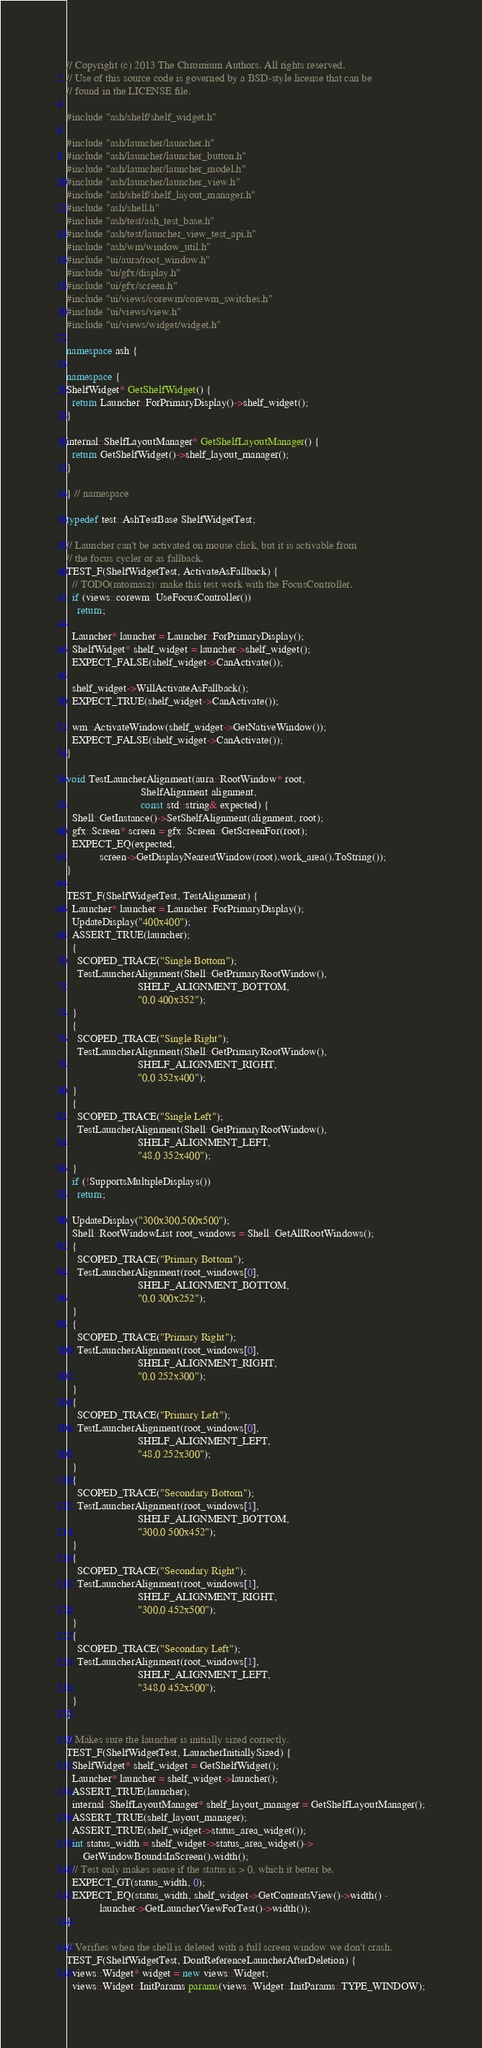Convert code to text. <code><loc_0><loc_0><loc_500><loc_500><_C++_>// Copyright (c) 2013 The Chromium Authors. All rights reserved.
// Use of this source code is governed by a BSD-style license that can be
// found in the LICENSE file.

#include "ash/shelf/shelf_widget.h"

#include "ash/launcher/launcher.h"
#include "ash/launcher/launcher_button.h"
#include "ash/launcher/launcher_model.h"
#include "ash/launcher/launcher_view.h"
#include "ash/shelf/shelf_layout_manager.h"
#include "ash/shell.h"
#include "ash/test/ash_test_base.h"
#include "ash/test/launcher_view_test_api.h"
#include "ash/wm/window_util.h"
#include "ui/aura/root_window.h"
#include "ui/gfx/display.h"
#include "ui/gfx/screen.h"
#include "ui/views/corewm/corewm_switches.h"
#include "ui/views/view.h"
#include "ui/views/widget/widget.h"

namespace ash {

namespace {
ShelfWidget* GetShelfWidget() {
  return Launcher::ForPrimaryDisplay()->shelf_widget();
}

internal::ShelfLayoutManager* GetShelfLayoutManager() {
  return GetShelfWidget()->shelf_layout_manager();
}

} // namespace

typedef test::AshTestBase ShelfWidgetTest;

// Launcher can't be activated on mouse click, but it is activable from
// the focus cycler or as fallback.
TEST_F(ShelfWidgetTest, ActivateAsFallback) {
  // TODO(mtomasz): make this test work with the FocusController.
  if (views::corewm::UseFocusController())
    return;

  Launcher* launcher = Launcher::ForPrimaryDisplay();
  ShelfWidget* shelf_widget = launcher->shelf_widget();
  EXPECT_FALSE(shelf_widget->CanActivate());

  shelf_widget->WillActivateAsFallback();
  EXPECT_TRUE(shelf_widget->CanActivate());

  wm::ActivateWindow(shelf_widget->GetNativeWindow());
  EXPECT_FALSE(shelf_widget->CanActivate());
}

void TestLauncherAlignment(aura::RootWindow* root,
                           ShelfAlignment alignment,
                           const std::string& expected) {
  Shell::GetInstance()->SetShelfAlignment(alignment, root);
  gfx::Screen* screen = gfx::Screen::GetScreenFor(root);
  EXPECT_EQ(expected,
            screen->GetDisplayNearestWindow(root).work_area().ToString());
}

TEST_F(ShelfWidgetTest, TestAlignment) {
  Launcher* launcher = Launcher::ForPrimaryDisplay();
  UpdateDisplay("400x400");
  ASSERT_TRUE(launcher);
  {
    SCOPED_TRACE("Single Bottom");
    TestLauncherAlignment(Shell::GetPrimaryRootWindow(),
                          SHELF_ALIGNMENT_BOTTOM,
                          "0,0 400x352");
  }
  {
    SCOPED_TRACE("Single Right");
    TestLauncherAlignment(Shell::GetPrimaryRootWindow(),
                          SHELF_ALIGNMENT_RIGHT,
                          "0,0 352x400");
  }
  {
    SCOPED_TRACE("Single Left");
    TestLauncherAlignment(Shell::GetPrimaryRootWindow(),
                          SHELF_ALIGNMENT_LEFT,
                          "48,0 352x400");
  }
  if (!SupportsMultipleDisplays())
    return;

  UpdateDisplay("300x300,500x500");
  Shell::RootWindowList root_windows = Shell::GetAllRootWindows();
  {
    SCOPED_TRACE("Primary Bottom");
    TestLauncherAlignment(root_windows[0],
                          SHELF_ALIGNMENT_BOTTOM,
                          "0,0 300x252");
  }
  {
    SCOPED_TRACE("Primary Right");
    TestLauncherAlignment(root_windows[0],
                          SHELF_ALIGNMENT_RIGHT,
                          "0,0 252x300");
  }
  {
    SCOPED_TRACE("Primary Left");
    TestLauncherAlignment(root_windows[0],
                          SHELF_ALIGNMENT_LEFT,
                          "48,0 252x300");
  }
  {
    SCOPED_TRACE("Secondary Bottom");
    TestLauncherAlignment(root_windows[1],
                          SHELF_ALIGNMENT_BOTTOM,
                          "300,0 500x452");
  }
  {
    SCOPED_TRACE("Secondary Right");
    TestLauncherAlignment(root_windows[1],
                          SHELF_ALIGNMENT_RIGHT,
                          "300,0 452x500");
  }
  {
    SCOPED_TRACE("Secondary Left");
    TestLauncherAlignment(root_windows[1],
                          SHELF_ALIGNMENT_LEFT,
                          "348,0 452x500");
  }
}

// Makes sure the launcher is initially sized correctly.
TEST_F(ShelfWidgetTest, LauncherInitiallySized) {
  ShelfWidget* shelf_widget = GetShelfWidget();
  Launcher* launcher = shelf_widget->launcher();
  ASSERT_TRUE(launcher);
  internal::ShelfLayoutManager* shelf_layout_manager = GetShelfLayoutManager();
  ASSERT_TRUE(shelf_layout_manager);
  ASSERT_TRUE(shelf_widget->status_area_widget());
  int status_width = shelf_widget->status_area_widget()->
      GetWindowBoundsInScreen().width();
  // Test only makes sense if the status is > 0, which it better be.
  EXPECT_GT(status_width, 0);
  EXPECT_EQ(status_width, shelf_widget->GetContentsView()->width() -
            launcher->GetLauncherViewForTest()->width());
}

// Verifies when the shell is deleted with a full screen window we don't crash.
TEST_F(ShelfWidgetTest, DontReferenceLauncherAfterDeletion) {
  views::Widget* widget = new views::Widget;
  views::Widget::InitParams params(views::Widget::InitParams::TYPE_WINDOW);</code> 